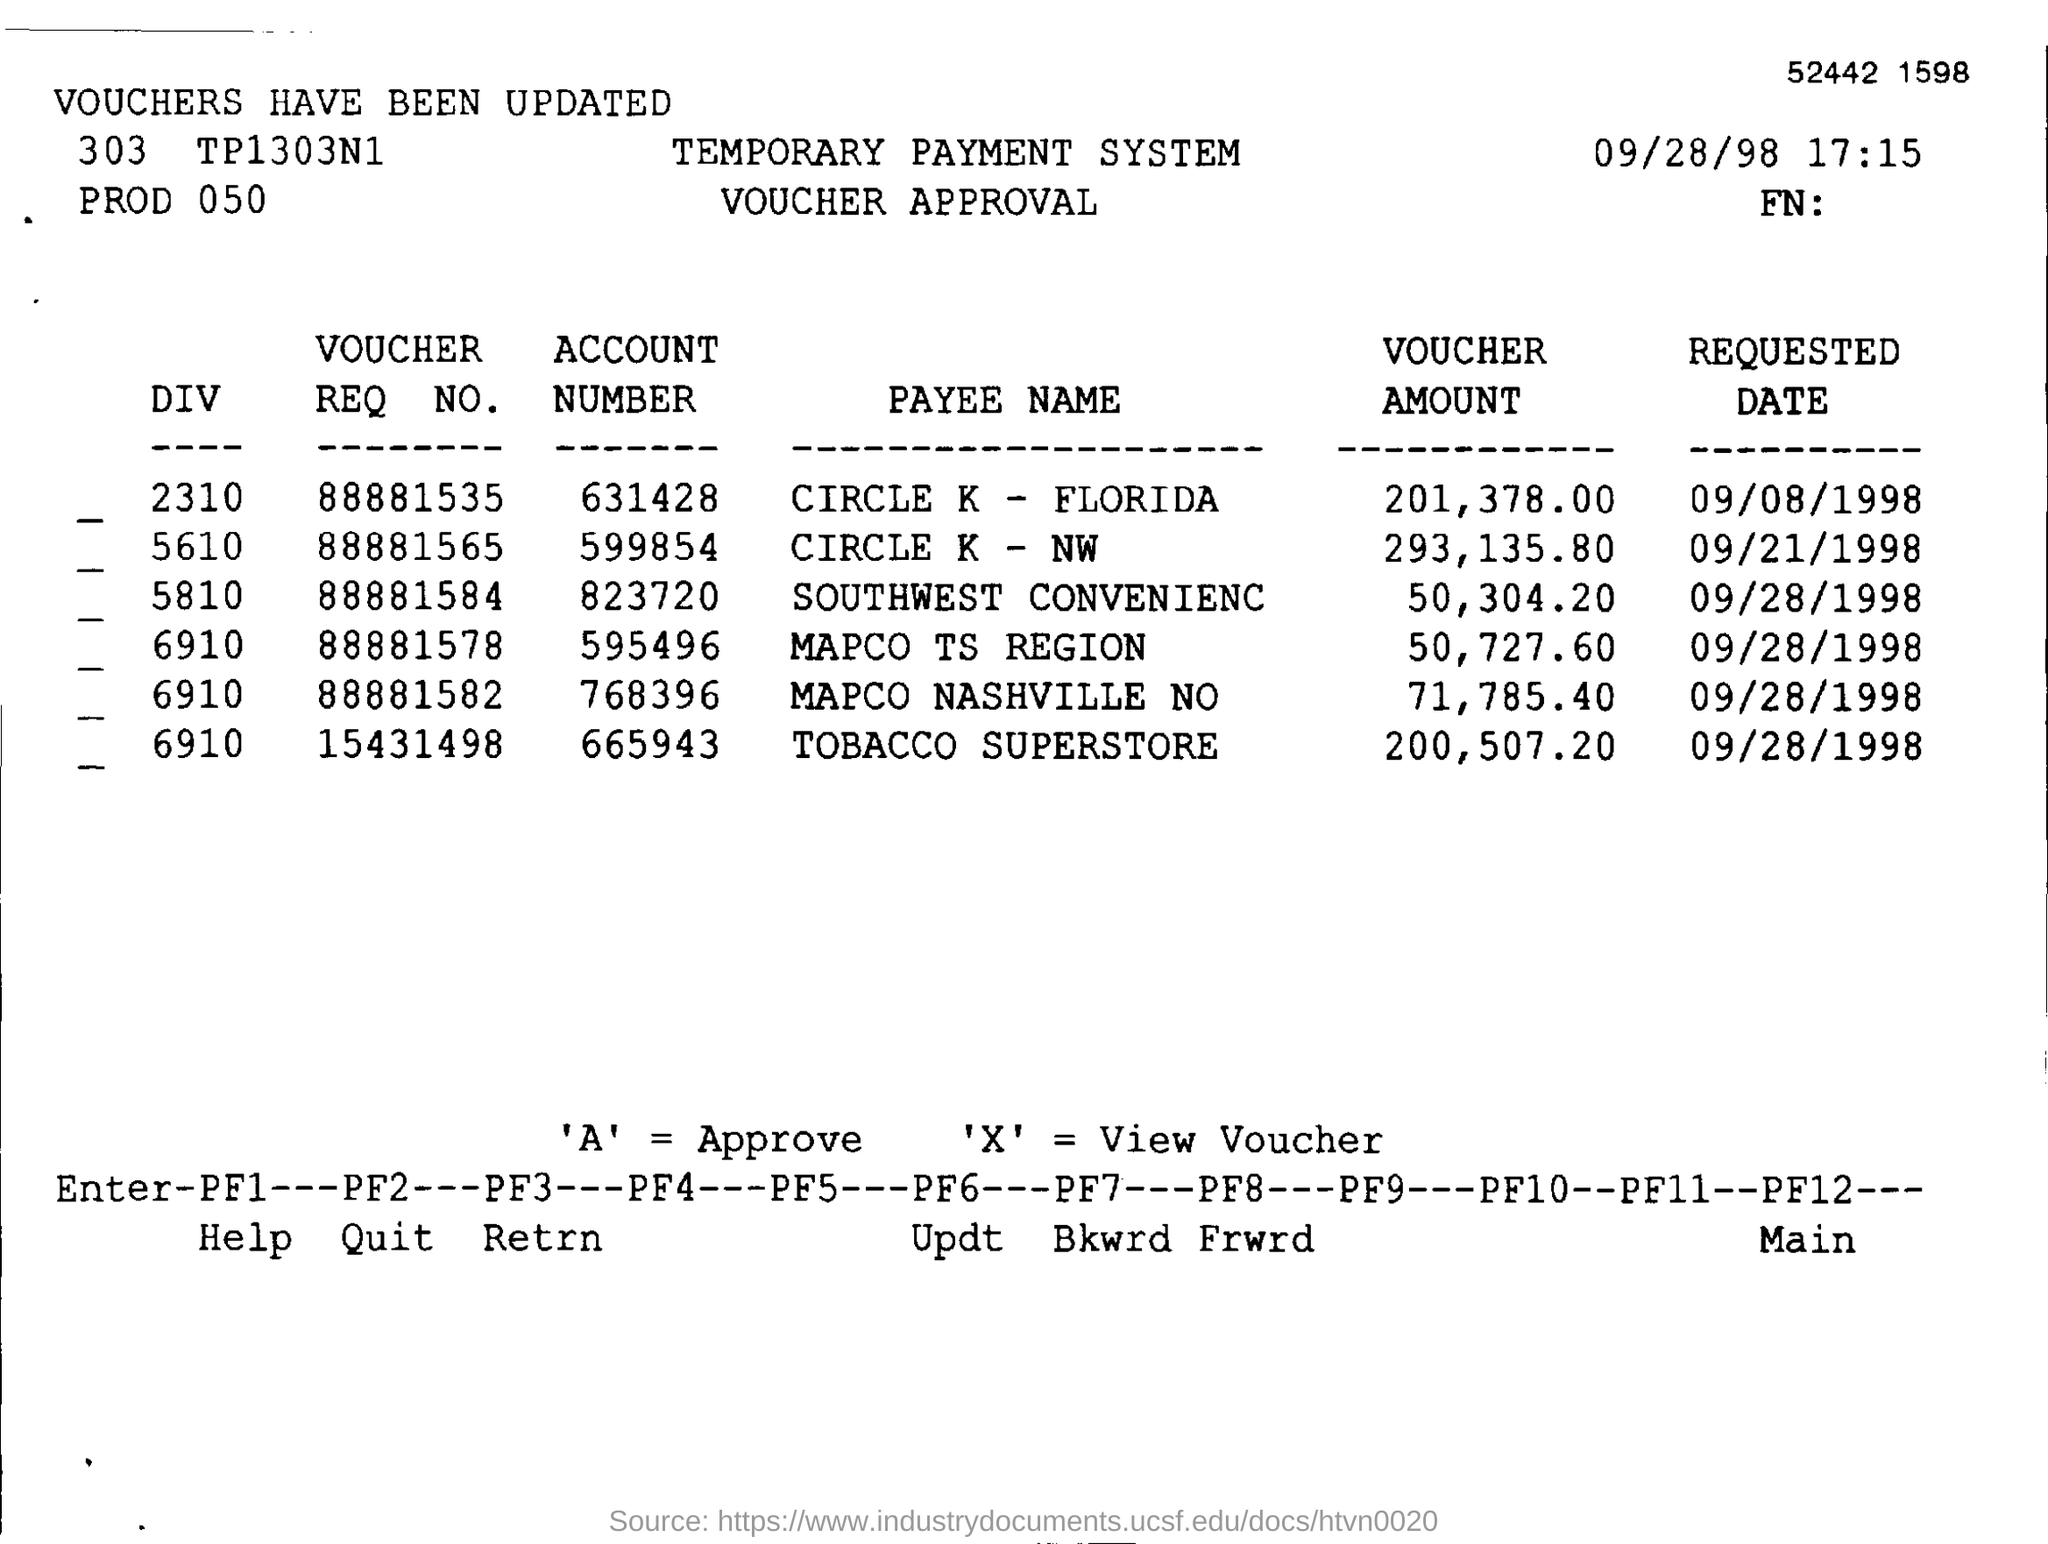Identify some key points in this picture. On what date was account number 631428 requested? The account number in the payee name of Circle K - Northwest is 599854. The voucher amount in the Payee Name of MAPCO TS REGION is 50,727.60. The payee name of TOBACCO SUPERSTORE is "What is the Voucher Req No. 15431498? The date and time mentioned in this document is September 28, 1998 at 5:15 PM. 